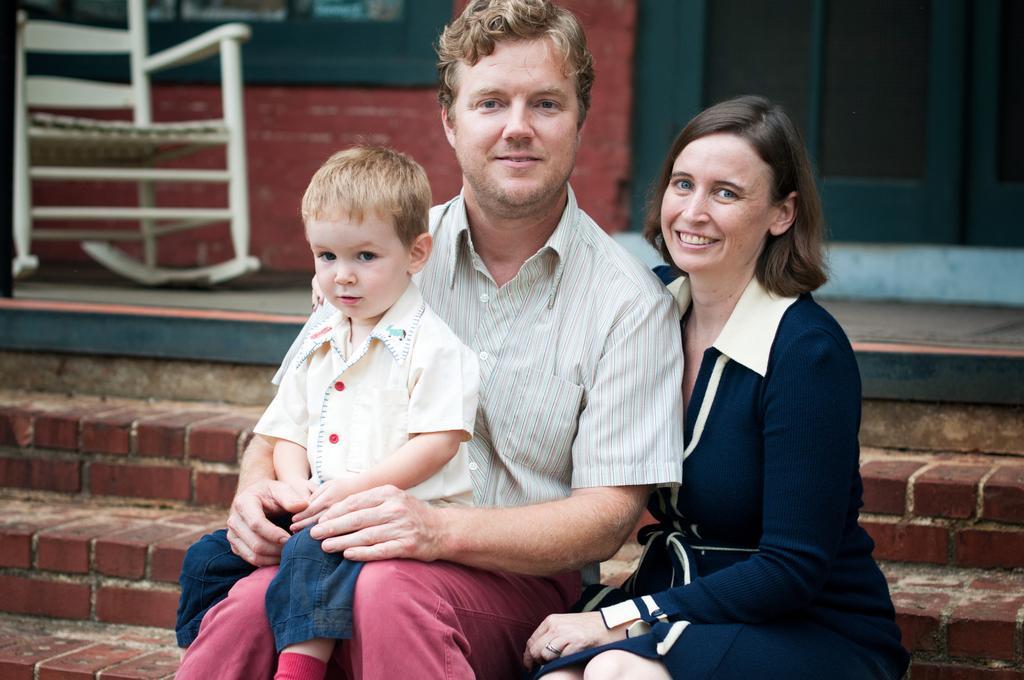Describe this image in one or two sentences. In this picture we have a couple and a kid sitting on stairs. They are looking and smiling at someone. 